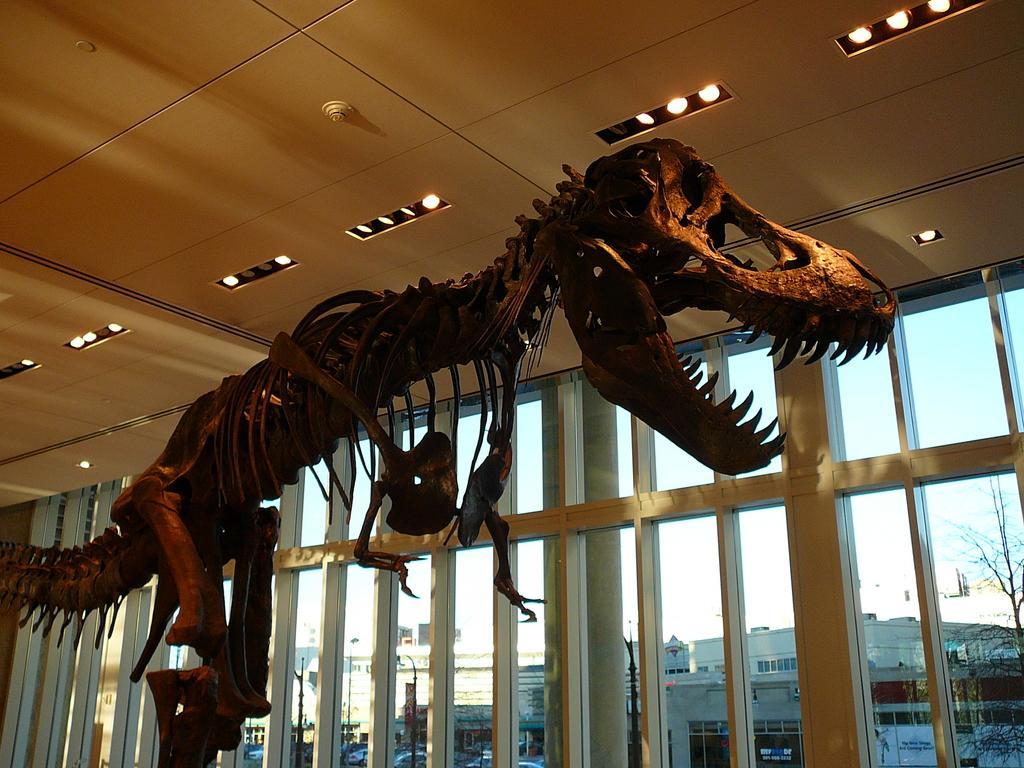Could you give a brief overview of what you see in this image? This image is clicked inside a room. There are lights at the top. There is a skeleton of a dinosaur in the middle. There is a tree on the right side. There are buildings at the bottom. 